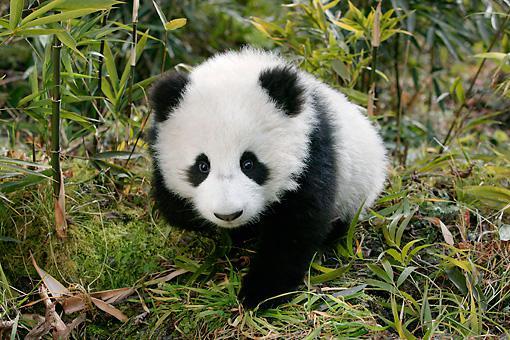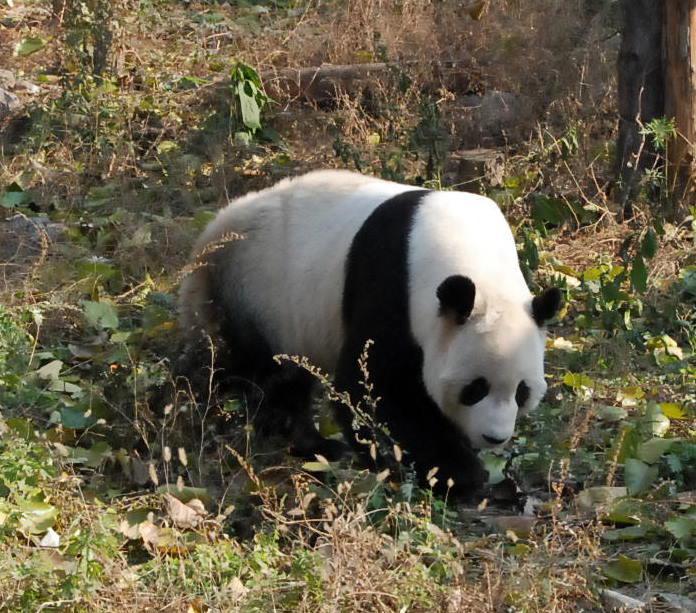The first image is the image on the left, the second image is the image on the right. Given the left and right images, does the statement "In at least one image therei sa panda with a single black stripe on it's back walking in grass white facing forward right." hold true? Answer yes or no. Yes. 